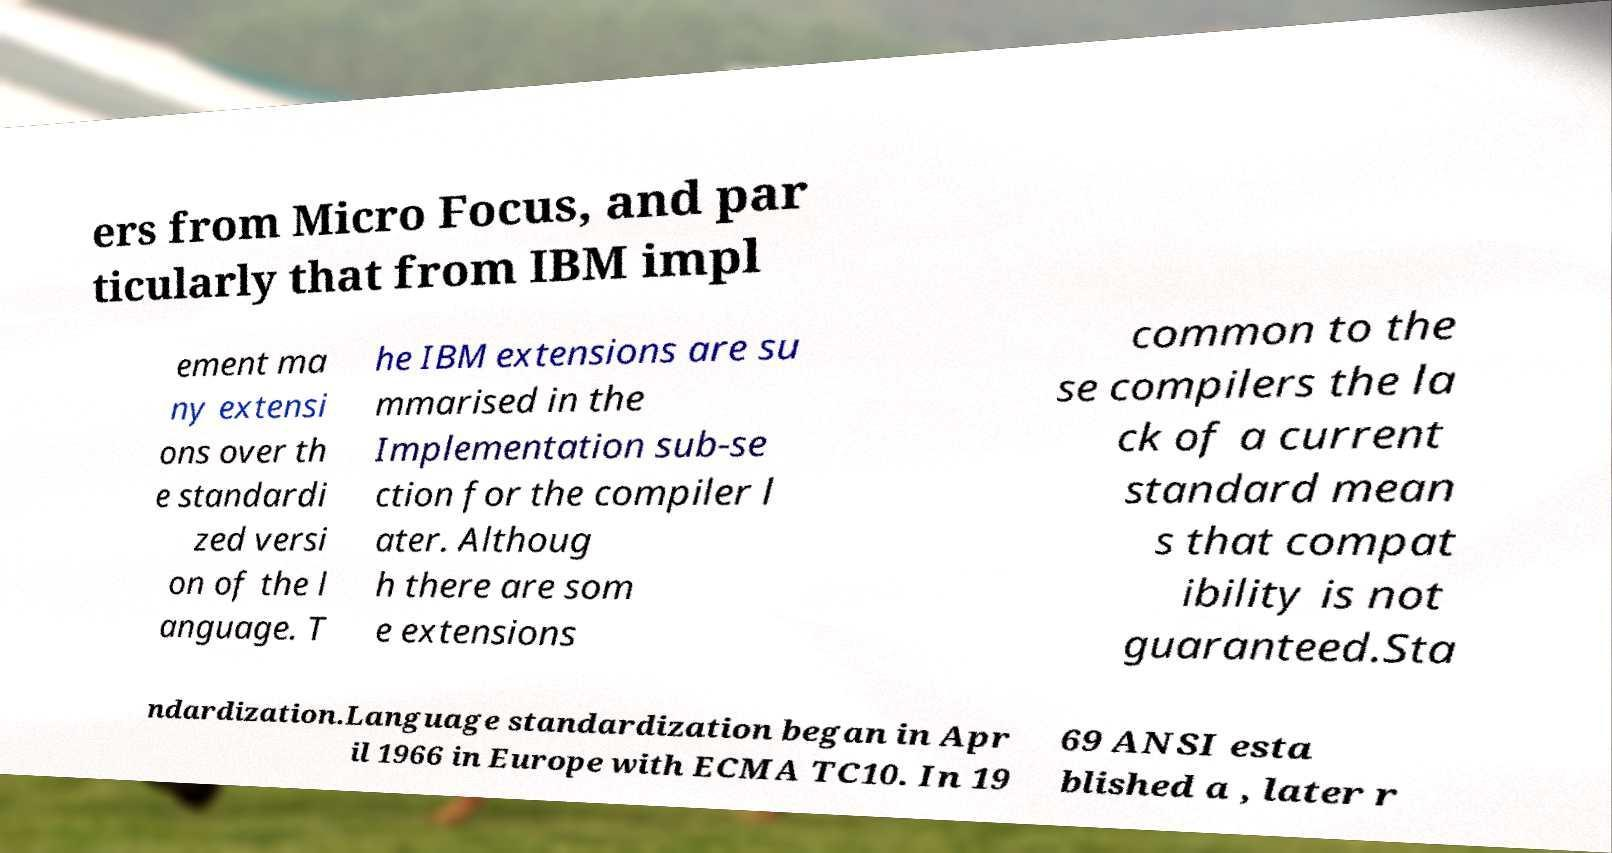Please read and relay the text visible in this image. What does it say? ers from Micro Focus, and par ticularly that from IBM impl ement ma ny extensi ons over th e standardi zed versi on of the l anguage. T he IBM extensions are su mmarised in the Implementation sub-se ction for the compiler l ater. Althoug h there are som e extensions common to the se compilers the la ck of a current standard mean s that compat ibility is not guaranteed.Sta ndardization.Language standardization began in Apr il 1966 in Europe with ECMA TC10. In 19 69 ANSI esta blished a , later r 